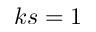Convert formula to latex. <formula><loc_0><loc_0><loc_500><loc_500>k s = 1</formula> 